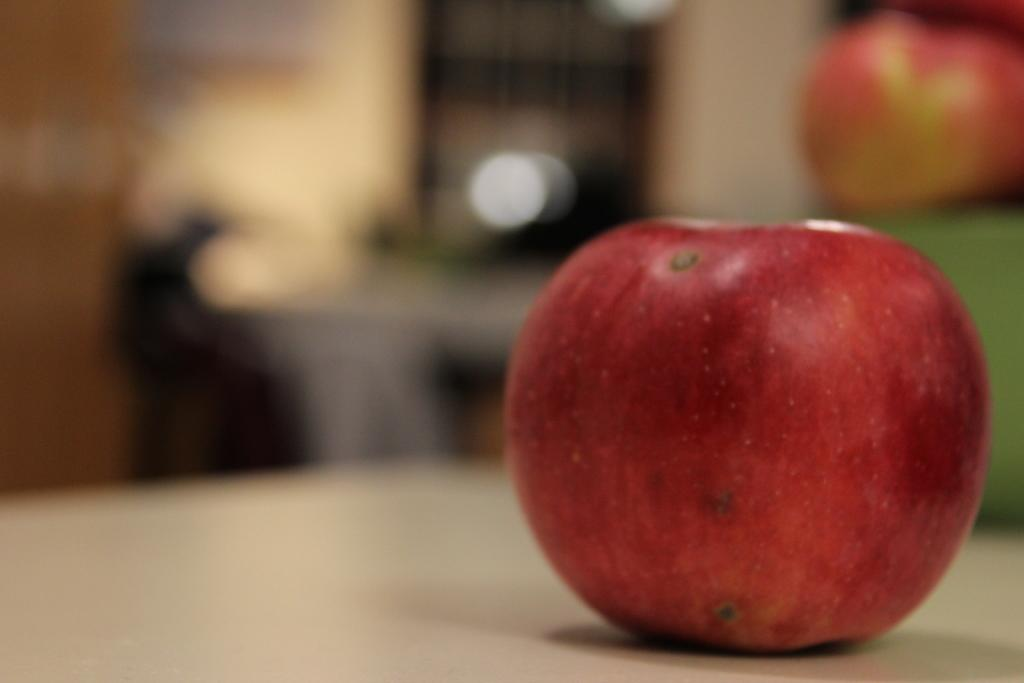What is the main object in the image? There is an apple in the image. Where is the apple located? The apple is on a surface. Can you describe the background of the image? The background of the image is blurred. How many cats are playing with the bubble in the image? There are no cats or bubbles present in the image; it features an apple on a surface with a blurred background. 